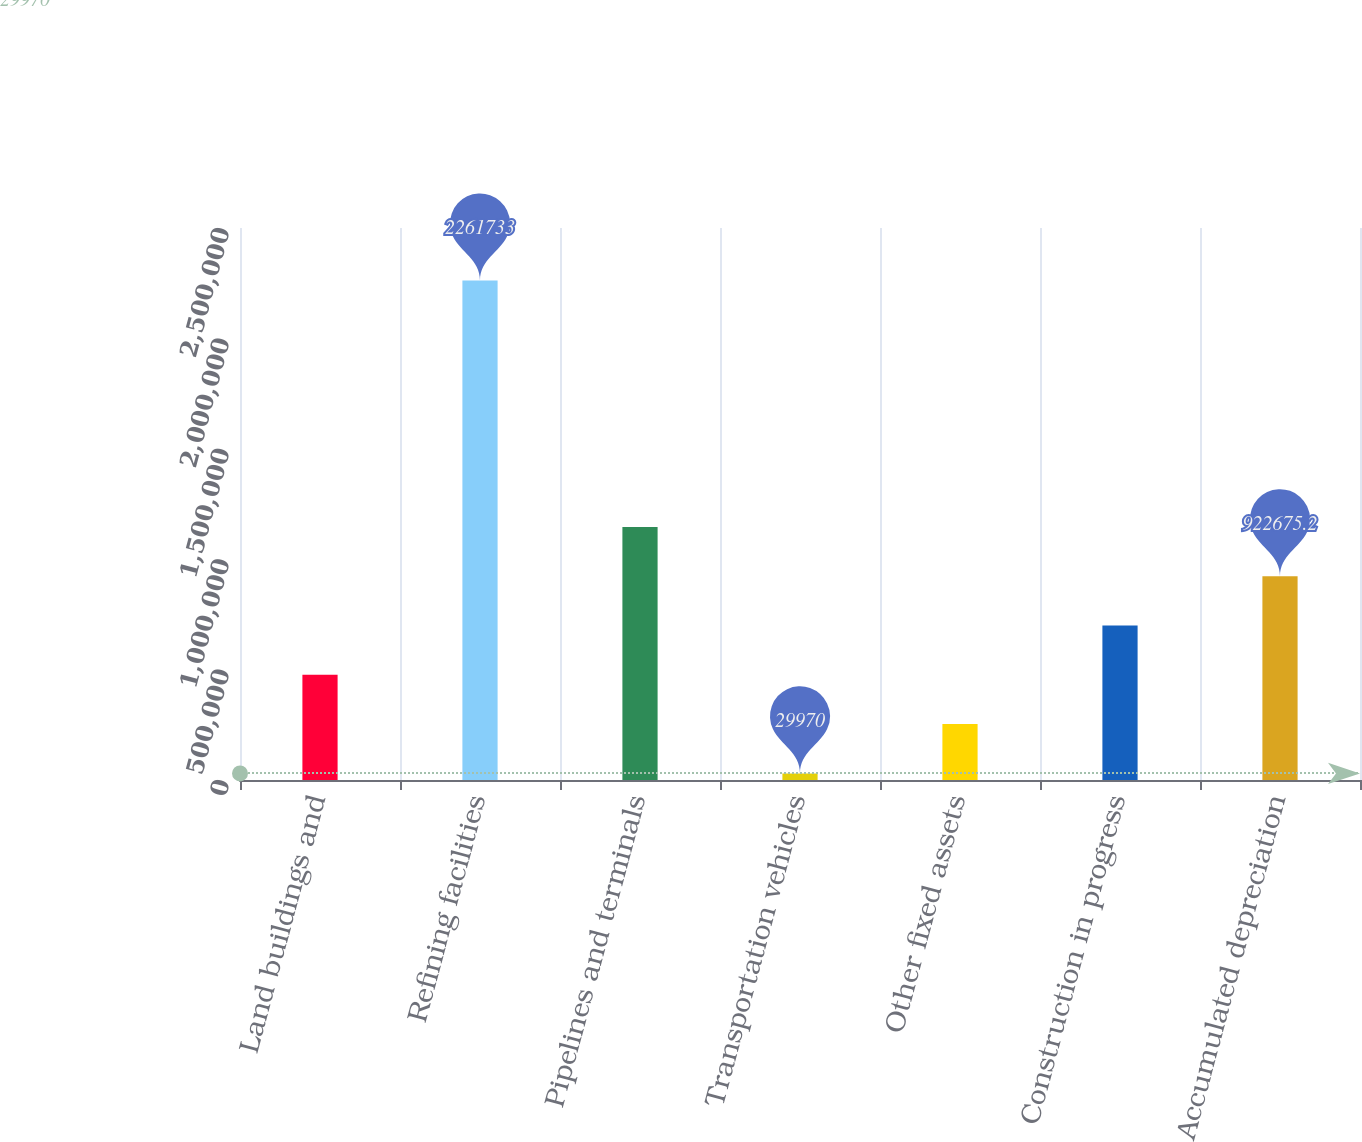<chart> <loc_0><loc_0><loc_500><loc_500><bar_chart><fcel>Land buildings and<fcel>Refining facilities<fcel>Pipelines and terminals<fcel>Transportation vehicles<fcel>Other fixed assets<fcel>Construction in progress<fcel>Accumulated depreciation<nl><fcel>476323<fcel>2.26173e+06<fcel>1.14585e+06<fcel>29970<fcel>253146<fcel>699499<fcel>922675<nl></chart> 